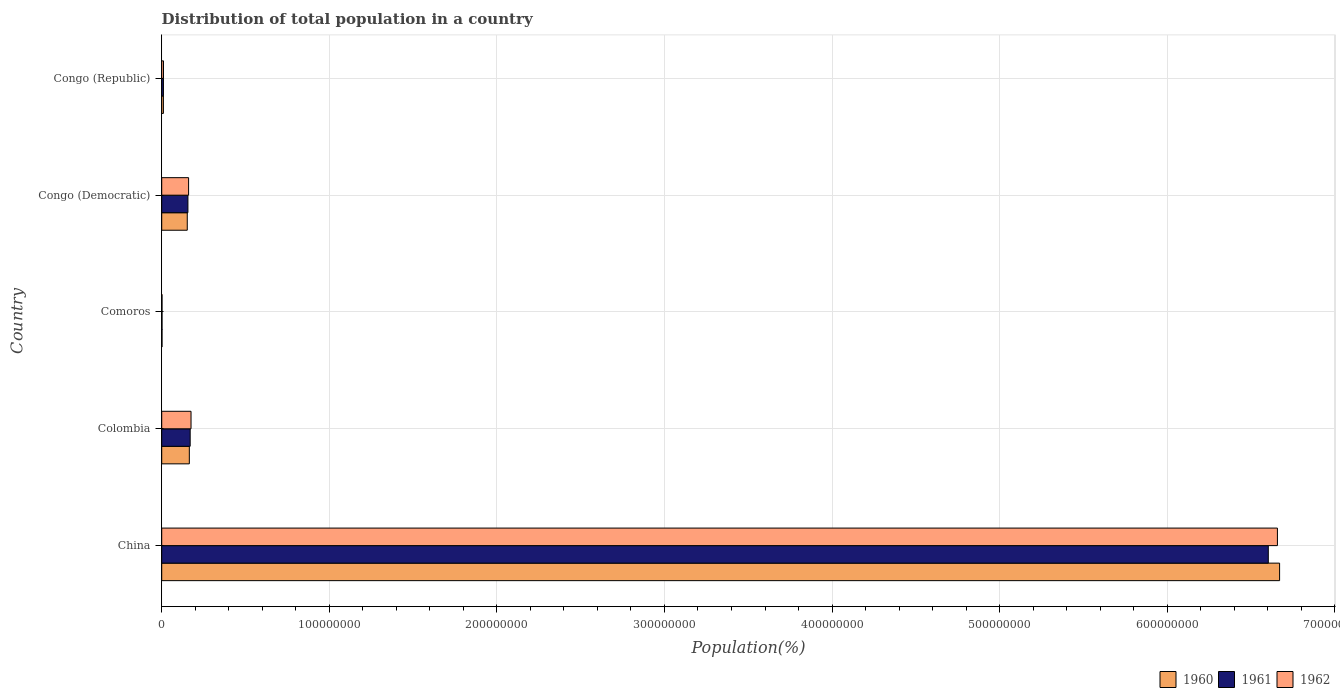How many different coloured bars are there?
Offer a terse response. 3. How many groups of bars are there?
Your answer should be very brief. 5. Are the number of bars per tick equal to the number of legend labels?
Provide a succinct answer. Yes. Are the number of bars on each tick of the Y-axis equal?
Your answer should be very brief. Yes. How many bars are there on the 5th tick from the top?
Ensure brevity in your answer.  3. How many bars are there on the 2nd tick from the bottom?
Ensure brevity in your answer.  3. What is the label of the 2nd group of bars from the top?
Your answer should be compact. Congo (Democratic). In how many cases, is the number of bars for a given country not equal to the number of legend labels?
Keep it short and to the point. 0. What is the population of in 1961 in Comoros?
Make the answer very short. 1.92e+05. Across all countries, what is the maximum population of in 1961?
Your response must be concise. 6.60e+08. Across all countries, what is the minimum population of in 1961?
Give a very brief answer. 1.92e+05. In which country was the population of in 1960 minimum?
Your response must be concise. Comoros. What is the total population of in 1962 in the graph?
Provide a short and direct response. 7.01e+08. What is the difference between the population of in 1962 in Comoros and that in Congo (Republic)?
Your answer should be very brief. -8.73e+05. What is the difference between the population of in 1961 in Comoros and the population of in 1962 in Congo (Republic)?
Offer a terse response. -8.76e+05. What is the average population of in 1962 per country?
Your answer should be very brief. 1.40e+08. What is the difference between the population of in 1961 and population of in 1960 in Congo (Democratic)?
Your answer should be very brief. 3.89e+05. What is the ratio of the population of in 1960 in Comoros to that in Congo (Democratic)?
Make the answer very short. 0.01. Is the population of in 1961 in China less than that in Comoros?
Offer a terse response. No. Is the difference between the population of in 1961 in China and Comoros greater than the difference between the population of in 1960 in China and Comoros?
Provide a succinct answer. No. What is the difference between the highest and the second highest population of in 1960?
Provide a short and direct response. 6.51e+08. What is the difference between the highest and the lowest population of in 1960?
Your answer should be compact. 6.67e+08. In how many countries, is the population of in 1962 greater than the average population of in 1962 taken over all countries?
Give a very brief answer. 1. What does the 2nd bar from the bottom in Congo (Republic) represents?
Provide a succinct answer. 1961. Is it the case that in every country, the sum of the population of in 1962 and population of in 1960 is greater than the population of in 1961?
Offer a terse response. Yes. How many bars are there?
Provide a short and direct response. 15. Are all the bars in the graph horizontal?
Your response must be concise. Yes. Does the graph contain grids?
Your response must be concise. Yes. What is the title of the graph?
Ensure brevity in your answer.  Distribution of total population in a country. Does "1988" appear as one of the legend labels in the graph?
Your response must be concise. No. What is the label or title of the X-axis?
Give a very brief answer. Population(%). What is the label or title of the Y-axis?
Make the answer very short. Country. What is the Population(%) in 1960 in China?
Ensure brevity in your answer.  6.67e+08. What is the Population(%) of 1961 in China?
Ensure brevity in your answer.  6.60e+08. What is the Population(%) of 1962 in China?
Keep it short and to the point. 6.66e+08. What is the Population(%) in 1960 in Colombia?
Your answer should be very brief. 1.65e+07. What is the Population(%) of 1961 in Colombia?
Provide a short and direct response. 1.70e+07. What is the Population(%) of 1962 in Colombia?
Offer a very short reply. 1.75e+07. What is the Population(%) of 1960 in Comoros?
Provide a succinct answer. 1.89e+05. What is the Population(%) in 1961 in Comoros?
Your response must be concise. 1.92e+05. What is the Population(%) of 1962 in Comoros?
Provide a short and direct response. 1.95e+05. What is the Population(%) in 1960 in Congo (Democratic)?
Give a very brief answer. 1.52e+07. What is the Population(%) of 1961 in Congo (Democratic)?
Offer a terse response. 1.56e+07. What is the Population(%) in 1962 in Congo (Democratic)?
Provide a short and direct response. 1.60e+07. What is the Population(%) of 1960 in Congo (Republic)?
Your response must be concise. 1.01e+06. What is the Population(%) of 1961 in Congo (Republic)?
Give a very brief answer. 1.04e+06. What is the Population(%) in 1962 in Congo (Republic)?
Make the answer very short. 1.07e+06. Across all countries, what is the maximum Population(%) in 1960?
Keep it short and to the point. 6.67e+08. Across all countries, what is the maximum Population(%) of 1961?
Keep it short and to the point. 6.60e+08. Across all countries, what is the maximum Population(%) in 1962?
Keep it short and to the point. 6.66e+08. Across all countries, what is the minimum Population(%) of 1960?
Keep it short and to the point. 1.89e+05. Across all countries, what is the minimum Population(%) in 1961?
Keep it short and to the point. 1.92e+05. Across all countries, what is the minimum Population(%) of 1962?
Provide a succinct answer. 1.95e+05. What is the total Population(%) of 1960 in the graph?
Make the answer very short. 7.00e+08. What is the total Population(%) of 1961 in the graph?
Make the answer very short. 6.94e+08. What is the total Population(%) of 1962 in the graph?
Keep it short and to the point. 7.01e+08. What is the difference between the Population(%) of 1960 in China and that in Colombia?
Make the answer very short. 6.51e+08. What is the difference between the Population(%) in 1961 in China and that in Colombia?
Your answer should be compact. 6.43e+08. What is the difference between the Population(%) in 1962 in China and that in Colombia?
Ensure brevity in your answer.  6.48e+08. What is the difference between the Population(%) of 1960 in China and that in Comoros?
Give a very brief answer. 6.67e+08. What is the difference between the Population(%) in 1961 in China and that in Comoros?
Make the answer very short. 6.60e+08. What is the difference between the Population(%) of 1962 in China and that in Comoros?
Keep it short and to the point. 6.66e+08. What is the difference between the Population(%) of 1960 in China and that in Congo (Democratic)?
Your answer should be very brief. 6.52e+08. What is the difference between the Population(%) in 1961 in China and that in Congo (Democratic)?
Provide a short and direct response. 6.45e+08. What is the difference between the Population(%) of 1962 in China and that in Congo (Democratic)?
Offer a very short reply. 6.50e+08. What is the difference between the Population(%) of 1960 in China and that in Congo (Republic)?
Offer a terse response. 6.66e+08. What is the difference between the Population(%) of 1961 in China and that in Congo (Republic)?
Keep it short and to the point. 6.59e+08. What is the difference between the Population(%) of 1962 in China and that in Congo (Republic)?
Give a very brief answer. 6.65e+08. What is the difference between the Population(%) in 1960 in Colombia and that in Comoros?
Your answer should be very brief. 1.63e+07. What is the difference between the Population(%) in 1961 in Colombia and that in Comoros?
Keep it short and to the point. 1.68e+07. What is the difference between the Population(%) of 1962 in Colombia and that in Comoros?
Give a very brief answer. 1.73e+07. What is the difference between the Population(%) in 1960 in Colombia and that in Congo (Democratic)?
Provide a succinct answer. 1.23e+06. What is the difference between the Population(%) in 1961 in Colombia and that in Congo (Democratic)?
Ensure brevity in your answer.  1.34e+06. What is the difference between the Population(%) of 1962 in Colombia and that in Congo (Democratic)?
Make the answer very short. 1.46e+06. What is the difference between the Population(%) of 1960 in Colombia and that in Congo (Republic)?
Offer a very short reply. 1.55e+07. What is the difference between the Population(%) of 1961 in Colombia and that in Congo (Republic)?
Keep it short and to the point. 1.59e+07. What is the difference between the Population(%) of 1962 in Colombia and that in Congo (Republic)?
Offer a terse response. 1.64e+07. What is the difference between the Population(%) of 1960 in Comoros and that in Congo (Democratic)?
Provide a short and direct response. -1.51e+07. What is the difference between the Population(%) of 1961 in Comoros and that in Congo (Democratic)?
Ensure brevity in your answer.  -1.54e+07. What is the difference between the Population(%) of 1962 in Comoros and that in Congo (Democratic)?
Your answer should be compact. -1.58e+07. What is the difference between the Population(%) of 1960 in Comoros and that in Congo (Republic)?
Provide a succinct answer. -8.25e+05. What is the difference between the Population(%) in 1961 in Comoros and that in Congo (Republic)?
Keep it short and to the point. -8.48e+05. What is the difference between the Population(%) in 1962 in Comoros and that in Congo (Republic)?
Offer a terse response. -8.73e+05. What is the difference between the Population(%) in 1960 in Congo (Democratic) and that in Congo (Republic)?
Your response must be concise. 1.42e+07. What is the difference between the Population(%) in 1961 in Congo (Democratic) and that in Congo (Republic)?
Make the answer very short. 1.46e+07. What is the difference between the Population(%) of 1962 in Congo (Democratic) and that in Congo (Republic)?
Give a very brief answer. 1.50e+07. What is the difference between the Population(%) in 1960 in China and the Population(%) in 1961 in Colombia?
Ensure brevity in your answer.  6.50e+08. What is the difference between the Population(%) of 1960 in China and the Population(%) of 1962 in Colombia?
Keep it short and to the point. 6.50e+08. What is the difference between the Population(%) in 1961 in China and the Population(%) in 1962 in Colombia?
Provide a succinct answer. 6.43e+08. What is the difference between the Population(%) of 1960 in China and the Population(%) of 1961 in Comoros?
Ensure brevity in your answer.  6.67e+08. What is the difference between the Population(%) of 1960 in China and the Population(%) of 1962 in Comoros?
Make the answer very short. 6.67e+08. What is the difference between the Population(%) of 1961 in China and the Population(%) of 1962 in Comoros?
Make the answer very short. 6.60e+08. What is the difference between the Population(%) in 1960 in China and the Population(%) in 1961 in Congo (Democratic)?
Ensure brevity in your answer.  6.51e+08. What is the difference between the Population(%) of 1960 in China and the Population(%) of 1962 in Congo (Democratic)?
Your response must be concise. 6.51e+08. What is the difference between the Population(%) in 1961 in China and the Population(%) in 1962 in Congo (Democratic)?
Keep it short and to the point. 6.44e+08. What is the difference between the Population(%) in 1960 in China and the Population(%) in 1961 in Congo (Republic)?
Provide a short and direct response. 6.66e+08. What is the difference between the Population(%) of 1960 in China and the Population(%) of 1962 in Congo (Republic)?
Keep it short and to the point. 6.66e+08. What is the difference between the Population(%) in 1961 in China and the Population(%) in 1962 in Congo (Republic)?
Provide a short and direct response. 6.59e+08. What is the difference between the Population(%) in 1960 in Colombia and the Population(%) in 1961 in Comoros?
Your response must be concise. 1.63e+07. What is the difference between the Population(%) in 1960 in Colombia and the Population(%) in 1962 in Comoros?
Your answer should be compact. 1.63e+07. What is the difference between the Population(%) of 1961 in Colombia and the Population(%) of 1962 in Comoros?
Give a very brief answer. 1.68e+07. What is the difference between the Population(%) of 1960 in Colombia and the Population(%) of 1961 in Congo (Democratic)?
Offer a very short reply. 8.43e+05. What is the difference between the Population(%) of 1960 in Colombia and the Population(%) of 1962 in Congo (Democratic)?
Provide a succinct answer. 4.39e+05. What is the difference between the Population(%) of 1961 in Colombia and the Population(%) of 1962 in Congo (Democratic)?
Your answer should be very brief. 9.41e+05. What is the difference between the Population(%) in 1960 in Colombia and the Population(%) in 1961 in Congo (Republic)?
Provide a short and direct response. 1.54e+07. What is the difference between the Population(%) of 1960 in Colombia and the Population(%) of 1962 in Congo (Republic)?
Give a very brief answer. 1.54e+07. What is the difference between the Population(%) in 1961 in Colombia and the Population(%) in 1962 in Congo (Republic)?
Provide a succinct answer. 1.59e+07. What is the difference between the Population(%) of 1960 in Comoros and the Population(%) of 1961 in Congo (Democratic)?
Offer a terse response. -1.54e+07. What is the difference between the Population(%) in 1960 in Comoros and the Population(%) in 1962 in Congo (Democratic)?
Offer a terse response. -1.59e+07. What is the difference between the Population(%) in 1961 in Comoros and the Population(%) in 1962 in Congo (Democratic)?
Your answer should be compact. -1.58e+07. What is the difference between the Population(%) of 1960 in Comoros and the Population(%) of 1961 in Congo (Republic)?
Provide a succinct answer. -8.51e+05. What is the difference between the Population(%) in 1960 in Comoros and the Population(%) in 1962 in Congo (Republic)?
Keep it short and to the point. -8.79e+05. What is the difference between the Population(%) in 1961 in Comoros and the Population(%) in 1962 in Congo (Republic)?
Offer a terse response. -8.76e+05. What is the difference between the Population(%) in 1960 in Congo (Democratic) and the Population(%) in 1961 in Congo (Republic)?
Offer a very short reply. 1.42e+07. What is the difference between the Population(%) in 1960 in Congo (Democratic) and the Population(%) in 1962 in Congo (Republic)?
Provide a short and direct response. 1.42e+07. What is the difference between the Population(%) of 1961 in Congo (Democratic) and the Population(%) of 1962 in Congo (Republic)?
Provide a succinct answer. 1.46e+07. What is the average Population(%) in 1960 per country?
Your response must be concise. 1.40e+08. What is the average Population(%) in 1961 per country?
Ensure brevity in your answer.  1.39e+08. What is the average Population(%) in 1962 per country?
Offer a terse response. 1.40e+08. What is the difference between the Population(%) of 1960 and Population(%) of 1961 in China?
Give a very brief answer. 6.74e+06. What is the difference between the Population(%) of 1960 and Population(%) of 1962 in China?
Offer a terse response. 1.30e+06. What is the difference between the Population(%) in 1961 and Population(%) in 1962 in China?
Ensure brevity in your answer.  -5.44e+06. What is the difference between the Population(%) in 1960 and Population(%) in 1961 in Colombia?
Offer a terse response. -5.02e+05. What is the difference between the Population(%) of 1960 and Population(%) of 1962 in Colombia?
Provide a short and direct response. -1.02e+06. What is the difference between the Population(%) of 1961 and Population(%) of 1962 in Colombia?
Offer a terse response. -5.18e+05. What is the difference between the Population(%) of 1960 and Population(%) of 1961 in Comoros?
Offer a very short reply. -3096. What is the difference between the Population(%) of 1960 and Population(%) of 1962 in Comoros?
Provide a short and direct response. -6228. What is the difference between the Population(%) in 1961 and Population(%) in 1962 in Comoros?
Ensure brevity in your answer.  -3132. What is the difference between the Population(%) of 1960 and Population(%) of 1961 in Congo (Democratic)?
Keep it short and to the point. -3.89e+05. What is the difference between the Population(%) of 1960 and Population(%) of 1962 in Congo (Democratic)?
Your answer should be very brief. -7.93e+05. What is the difference between the Population(%) of 1961 and Population(%) of 1962 in Congo (Democratic)?
Make the answer very short. -4.04e+05. What is the difference between the Population(%) in 1960 and Population(%) in 1961 in Congo (Republic)?
Provide a short and direct response. -2.64e+04. What is the difference between the Population(%) in 1960 and Population(%) in 1962 in Congo (Republic)?
Keep it short and to the point. -5.40e+04. What is the difference between the Population(%) in 1961 and Population(%) in 1962 in Congo (Republic)?
Make the answer very short. -2.76e+04. What is the ratio of the Population(%) of 1960 in China to that in Colombia?
Provide a short and direct response. 40.48. What is the ratio of the Population(%) of 1961 in China to that in Colombia?
Give a very brief answer. 38.88. What is the ratio of the Population(%) of 1962 in China to that in Colombia?
Your response must be concise. 38.04. What is the ratio of the Population(%) of 1960 in China to that in Comoros?
Your answer should be compact. 3534.48. What is the ratio of the Population(%) in 1961 in China to that in Comoros?
Your answer should be very brief. 3442.3. What is the ratio of the Population(%) of 1962 in China to that in Comoros?
Provide a succinct answer. 3414.91. What is the ratio of the Population(%) in 1960 in China to that in Congo (Democratic)?
Your response must be concise. 43.75. What is the ratio of the Population(%) of 1961 in China to that in Congo (Democratic)?
Your response must be concise. 42.23. What is the ratio of the Population(%) of 1962 in China to that in Congo (Democratic)?
Offer a terse response. 41.5. What is the ratio of the Population(%) of 1960 in China to that in Congo (Republic)?
Provide a short and direct response. 658.13. What is the ratio of the Population(%) of 1961 in China to that in Congo (Republic)?
Your answer should be very brief. 634.95. What is the ratio of the Population(%) of 1962 in China to that in Congo (Republic)?
Offer a very short reply. 623.61. What is the ratio of the Population(%) of 1960 in Colombia to that in Comoros?
Provide a short and direct response. 87.32. What is the ratio of the Population(%) in 1961 in Colombia to that in Comoros?
Your answer should be compact. 88.53. What is the ratio of the Population(%) of 1962 in Colombia to that in Comoros?
Offer a terse response. 89.76. What is the ratio of the Population(%) in 1960 in Colombia to that in Congo (Democratic)?
Provide a short and direct response. 1.08. What is the ratio of the Population(%) of 1961 in Colombia to that in Congo (Democratic)?
Your response must be concise. 1.09. What is the ratio of the Population(%) in 1962 in Colombia to that in Congo (Democratic)?
Your response must be concise. 1.09. What is the ratio of the Population(%) of 1960 in Colombia to that in Congo (Republic)?
Make the answer very short. 16.26. What is the ratio of the Population(%) of 1961 in Colombia to that in Congo (Republic)?
Offer a terse response. 16.33. What is the ratio of the Population(%) in 1962 in Colombia to that in Congo (Republic)?
Your answer should be very brief. 16.39. What is the ratio of the Population(%) of 1960 in Comoros to that in Congo (Democratic)?
Make the answer very short. 0.01. What is the ratio of the Population(%) in 1961 in Comoros to that in Congo (Democratic)?
Your answer should be compact. 0.01. What is the ratio of the Population(%) in 1962 in Comoros to that in Congo (Democratic)?
Give a very brief answer. 0.01. What is the ratio of the Population(%) in 1960 in Comoros to that in Congo (Republic)?
Your answer should be very brief. 0.19. What is the ratio of the Population(%) in 1961 in Comoros to that in Congo (Republic)?
Offer a terse response. 0.18. What is the ratio of the Population(%) of 1962 in Comoros to that in Congo (Republic)?
Your answer should be compact. 0.18. What is the ratio of the Population(%) in 1960 in Congo (Democratic) to that in Congo (Republic)?
Make the answer very short. 15.04. What is the ratio of the Population(%) of 1961 in Congo (Democratic) to that in Congo (Republic)?
Make the answer very short. 15.04. What is the ratio of the Population(%) in 1962 in Congo (Democratic) to that in Congo (Republic)?
Provide a succinct answer. 15.03. What is the difference between the highest and the second highest Population(%) in 1960?
Provide a succinct answer. 6.51e+08. What is the difference between the highest and the second highest Population(%) of 1961?
Provide a succinct answer. 6.43e+08. What is the difference between the highest and the second highest Population(%) of 1962?
Give a very brief answer. 6.48e+08. What is the difference between the highest and the lowest Population(%) of 1960?
Keep it short and to the point. 6.67e+08. What is the difference between the highest and the lowest Population(%) in 1961?
Give a very brief answer. 6.60e+08. What is the difference between the highest and the lowest Population(%) of 1962?
Offer a very short reply. 6.66e+08. 